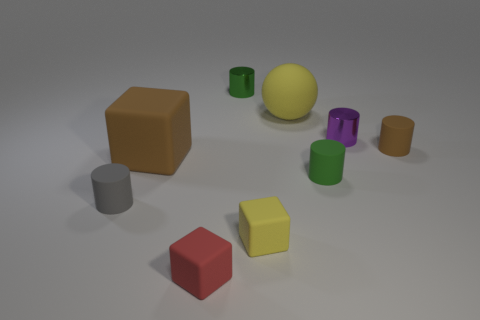What color is the metallic cylinder on the right side of the green cylinder in front of the brown thing that is left of the tiny yellow thing?
Offer a terse response. Purple. There is a red thing that is the same size as the gray matte object; what is its material?
Your answer should be compact. Rubber. How many objects are tiny rubber cubes behind the small red object or yellow matte objects?
Your response must be concise. 2. Is there a large metallic block?
Your answer should be very brief. No. There is a green object that is behind the tiny brown rubber cylinder; what material is it?
Your answer should be very brief. Metal. There is a tiny cylinder that is the same color as the large matte cube; what material is it?
Offer a very short reply. Rubber. How many large things are red things or gray cylinders?
Keep it short and to the point. 0. The large rubber cube is what color?
Your response must be concise. Brown. There is a tiny thing to the right of the small purple cylinder; is there a red object that is to the right of it?
Offer a terse response. No. Is the number of green metallic objects in front of the small red matte cube less than the number of tiny yellow things?
Offer a very short reply. Yes. 